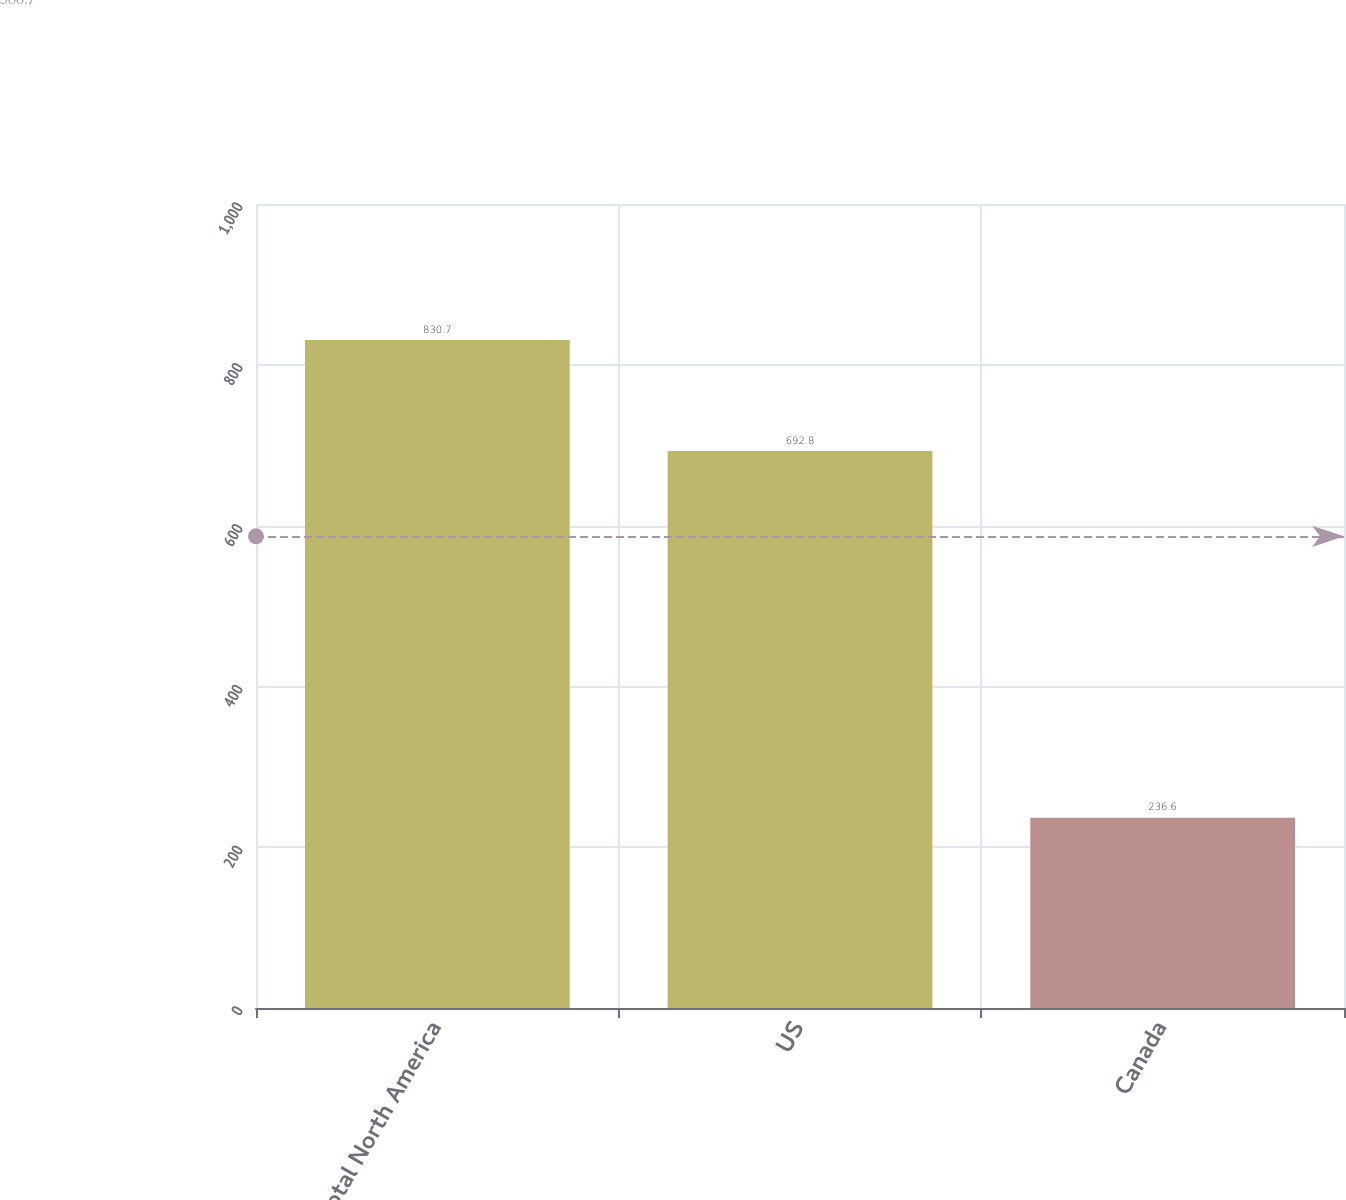Convert chart. <chart><loc_0><loc_0><loc_500><loc_500><bar_chart><fcel>Total North America<fcel>US<fcel>Canada<nl><fcel>830.7<fcel>692.8<fcel>236.6<nl></chart> 